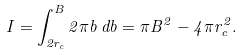Convert formula to latex. <formula><loc_0><loc_0><loc_500><loc_500>I = \int _ { 2 r _ { c } } ^ { B } 2 \pi b \, d b = \pi B ^ { 2 } - 4 \pi r _ { c } ^ { 2 } .</formula> 